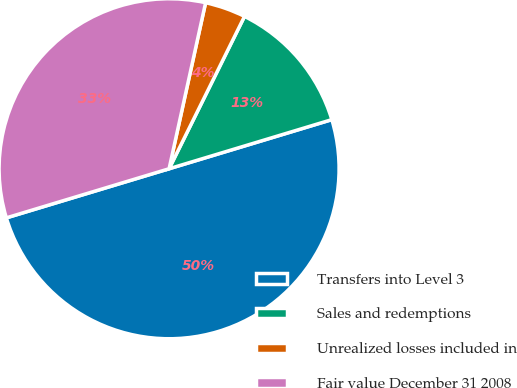<chart> <loc_0><loc_0><loc_500><loc_500><pie_chart><fcel>Transfers into Level 3<fcel>Sales and redemptions<fcel>Unrealized losses included in<fcel>Fair value December 31 2008<nl><fcel>50.0%<fcel>13.02%<fcel>3.87%<fcel>33.11%<nl></chart> 